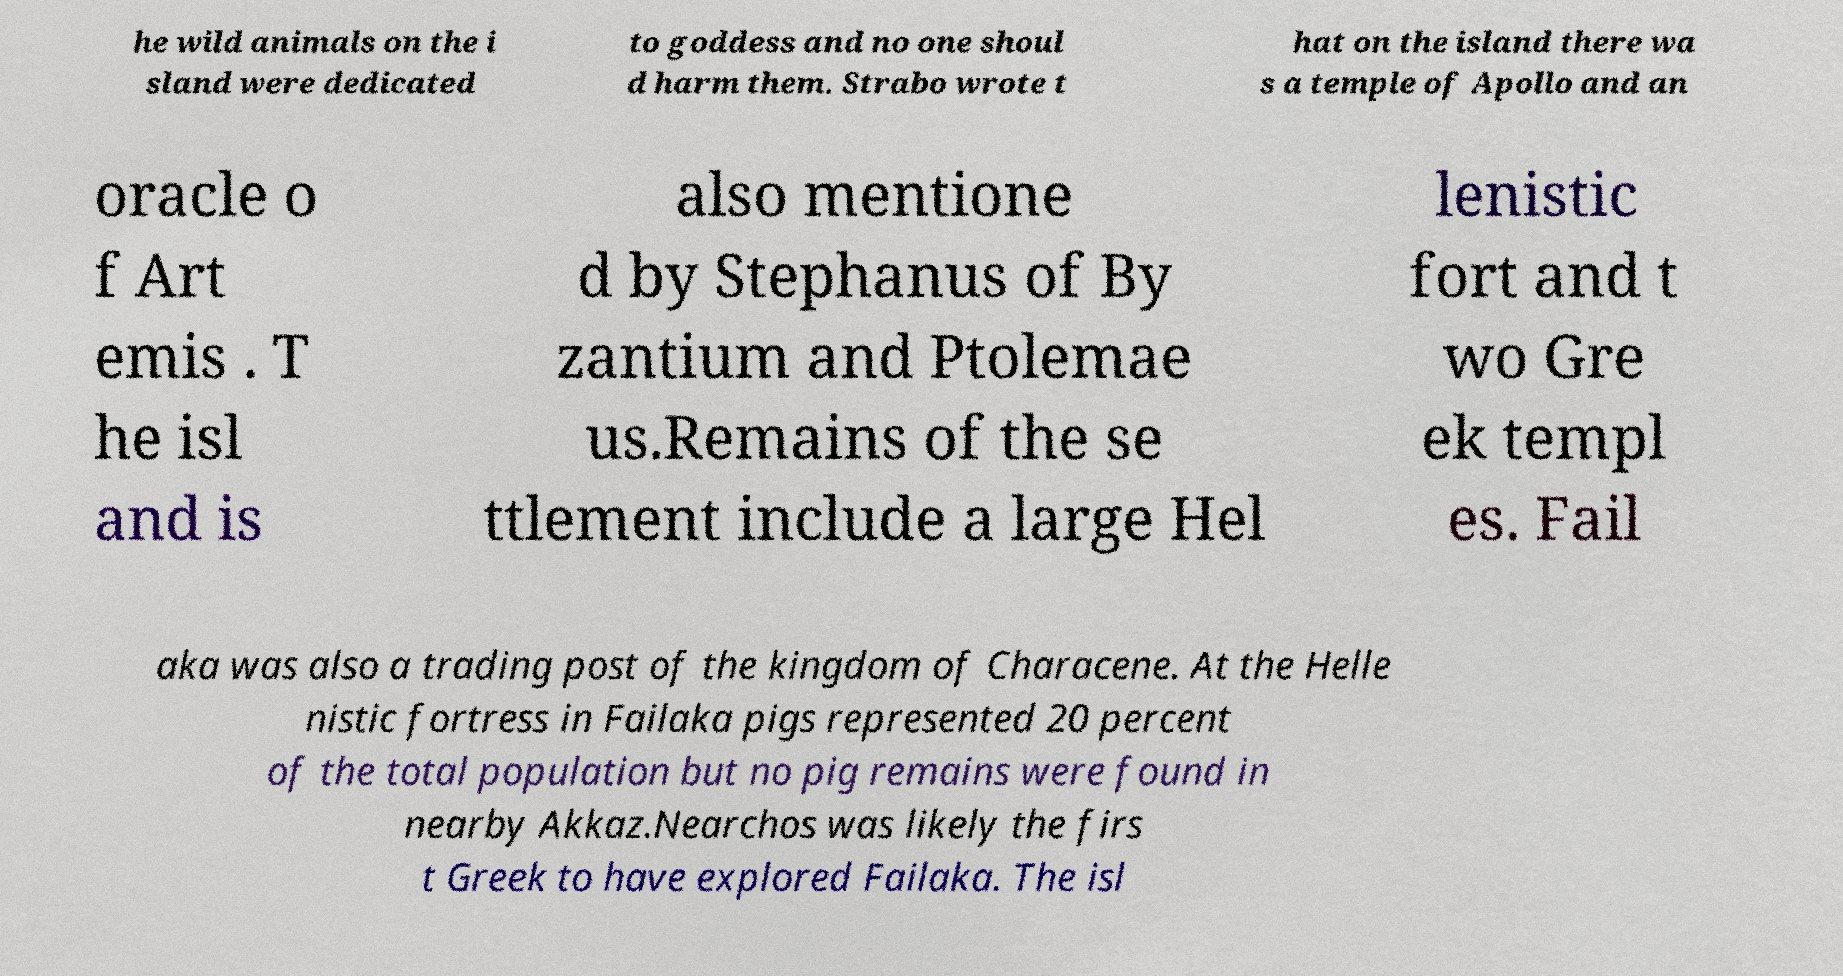Could you extract and type out the text from this image? he wild animals on the i sland were dedicated to goddess and no one shoul d harm them. Strabo wrote t hat on the island there wa s a temple of Apollo and an oracle o f Art emis . T he isl and is also mentione d by Stephanus of By zantium and Ptolemae us.Remains of the se ttlement include a large Hel lenistic fort and t wo Gre ek templ es. Fail aka was also a trading post of the kingdom of Characene. At the Helle nistic fortress in Failaka pigs represented 20 percent of the total population but no pig remains were found in nearby Akkaz.Nearchos was likely the firs t Greek to have explored Failaka. The isl 